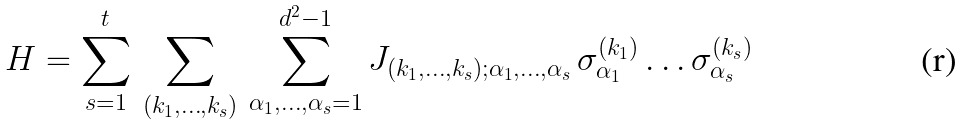Convert formula to latex. <formula><loc_0><loc_0><loc_500><loc_500>H = \sum _ { s = 1 } ^ { t } \, \sum _ { ( k _ { 1 } , \dots , k _ { s } ) } \, \sum _ { \alpha _ { 1 } , \dots , \alpha _ { s } = 1 } ^ { d ^ { 2 } - 1 } J _ { ( k _ { 1 } , \dots , k _ { s } ) ; \alpha _ { 1 } , \dots , \alpha _ { s } } \, \sigma _ { \alpha _ { 1 } } ^ { ( k _ { 1 } ) } \dots \sigma _ { \alpha _ { s } } ^ { ( k _ { s } ) }</formula> 